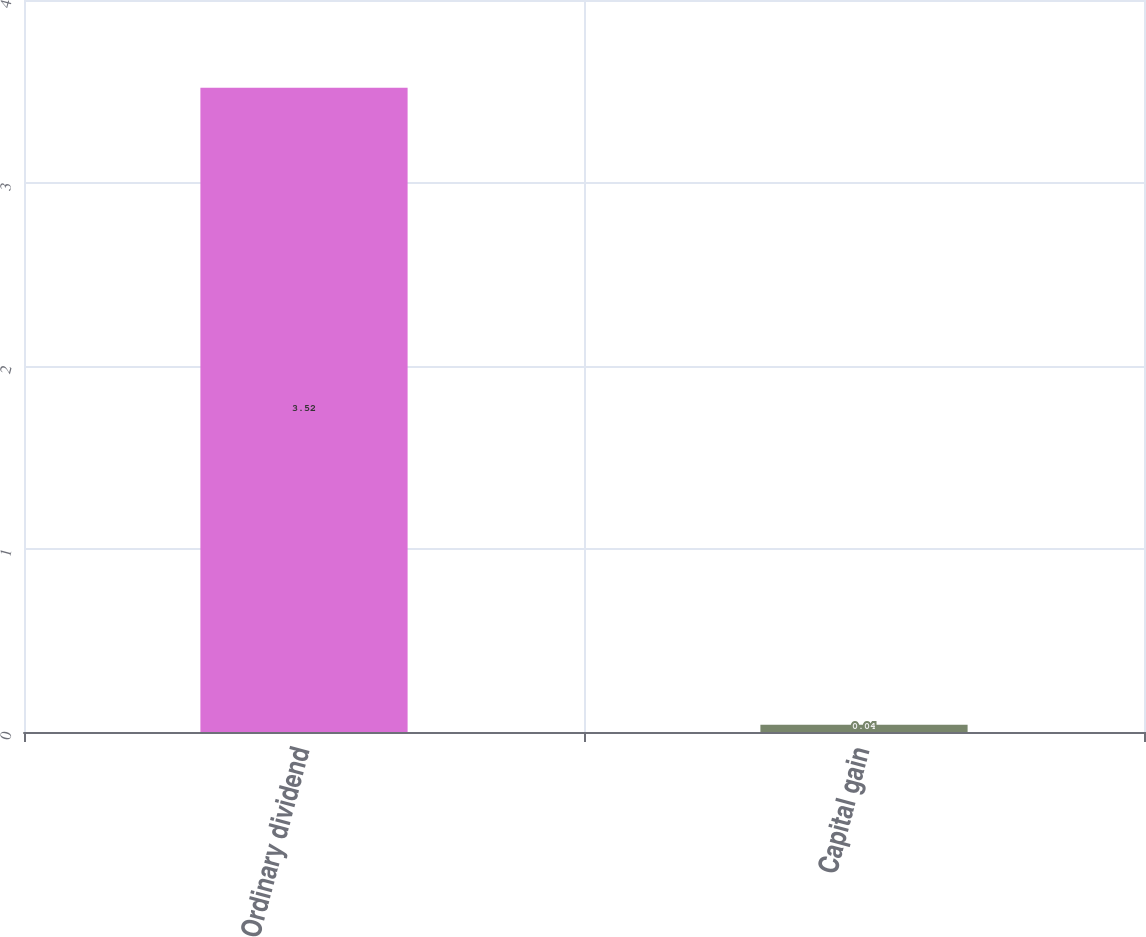Convert chart to OTSL. <chart><loc_0><loc_0><loc_500><loc_500><bar_chart><fcel>Ordinary dividend<fcel>Capital gain<nl><fcel>3.52<fcel>0.04<nl></chart> 